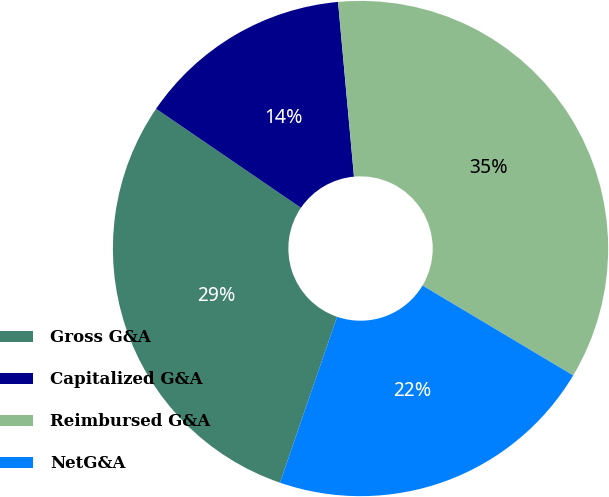<chart> <loc_0><loc_0><loc_500><loc_500><pie_chart><fcel>Gross G&A<fcel>Capitalized G&A<fcel>Reimbursed G&A<fcel>NetG&A<nl><fcel>29.27%<fcel>14.01%<fcel>35.01%<fcel>21.71%<nl></chart> 